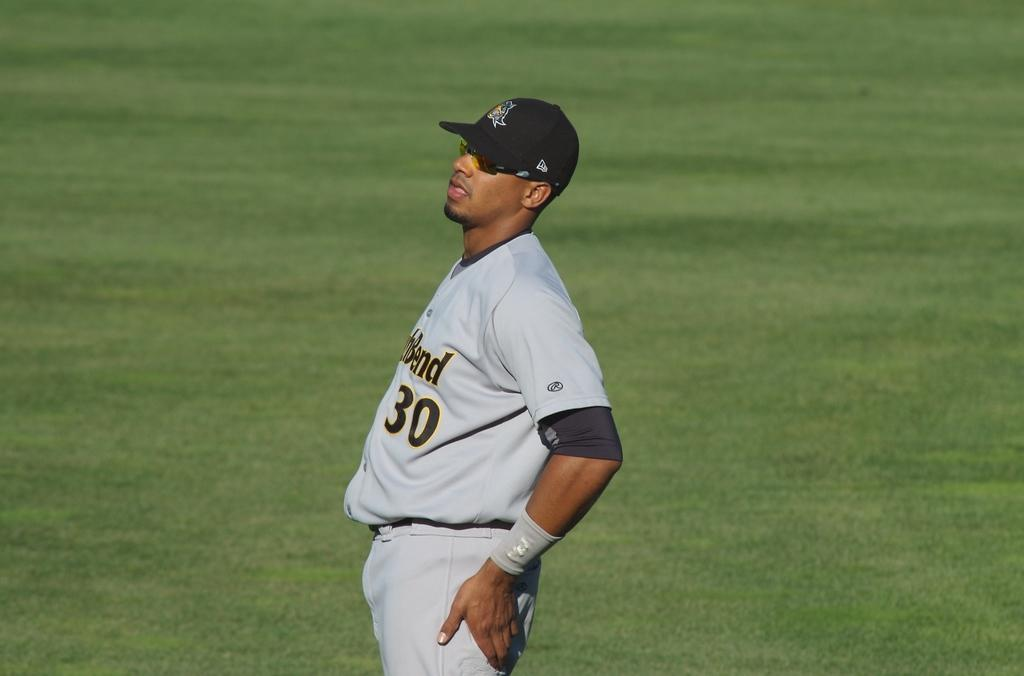<image>
Present a compact description of the photo's key features. A ball player stands in the field wearing a number 30 uniform. 